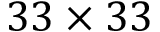Convert formula to latex. <formula><loc_0><loc_0><loc_500><loc_500>3 3 \times 3 3</formula> 